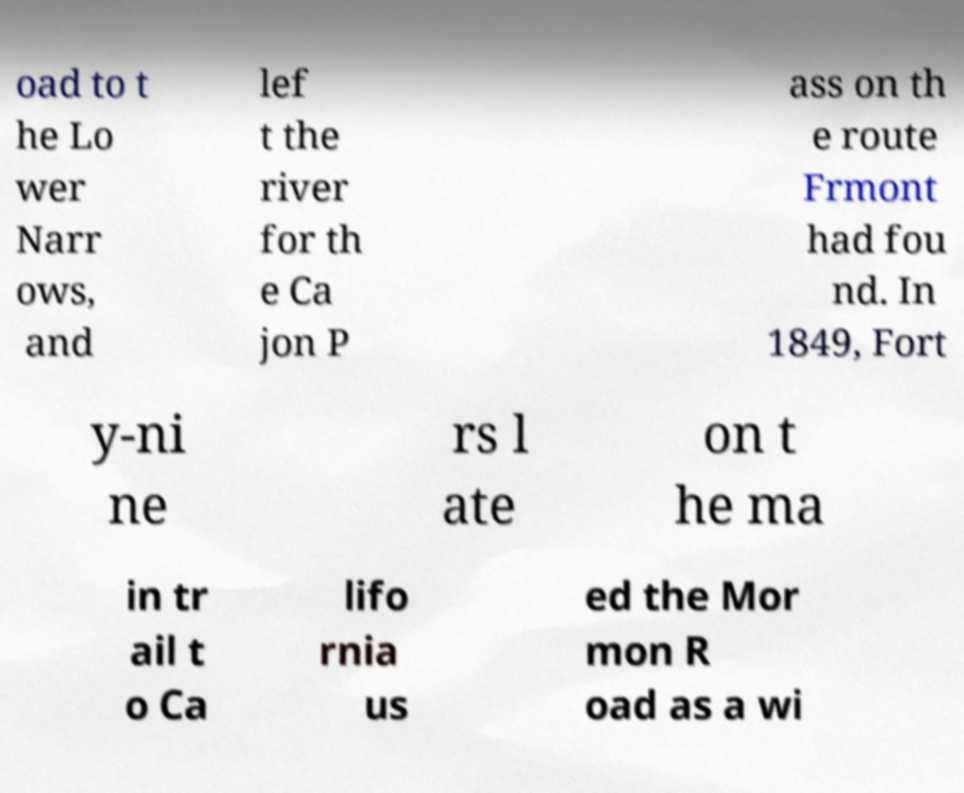Please identify and transcribe the text found in this image. oad to t he Lo wer Narr ows, and lef t the river for th e Ca jon P ass on th e route Frmont had fou nd. In 1849, Fort y-ni ne rs l ate on t he ma in tr ail t o Ca lifo rnia us ed the Mor mon R oad as a wi 